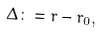Convert formula to latex. <formula><loc_0><loc_0><loc_500><loc_500>\Delta \colon = r - r _ { 0 } ,</formula> 